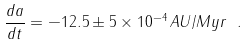<formula> <loc_0><loc_0><loc_500><loc_500>\frac { d a } { d t } = - 1 2 . 5 \pm 5 \times 1 0 ^ { - 4 } \, A U / M y r \ .</formula> 